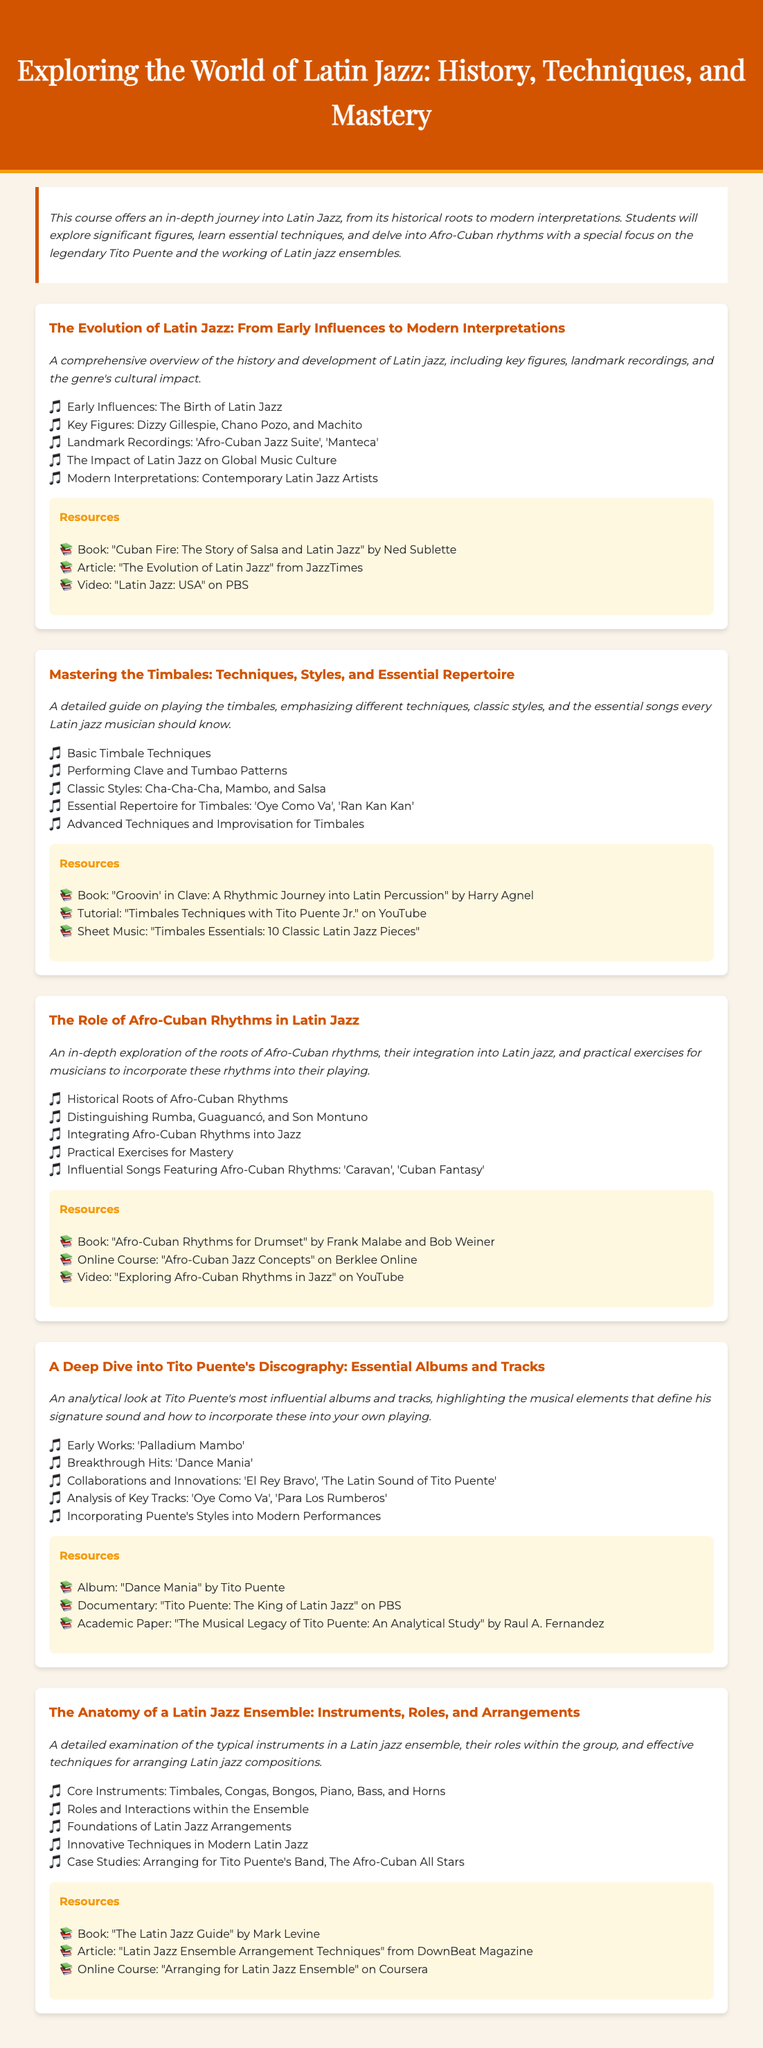What is the title of the course? The title of the course is provided at the top of the document, which highlights the key themes of the syllabus.
Answer: Exploring the World of Latin Jazz: History, Techniques, and Mastery Who is a key figure mentioned in the module about the evolution of Latin jazz? This question looks for specific names listed under the 'Key Figures' bullet point in the first module.
Answer: Dizzy Gillespie What is one essential song every Latin jazz musician should know according to the timbales module? This question focuses on identifying a specific song listed as part of the essential repertoire in the timbales section.
Answer: Oye Como Va How many major modules are included in the syllabus? The number of major modules is stated by counting the distinct sections outlined in the document.
Answer: Five Which book is recommended for learning about Afro-Cuban rhythms? The question looks for a specific title indicated in the resources section of the Afro-Cuban rhythms module.
Answer: Afro-Cuban Rhythms for Drumset What are the core instruments listed in the anatomy of a Latin jazz ensemble module? This question asks for the specific instruments mentioned in the 'Core Instruments' bullet point.
Answer: Timbales, Congas, Bongos, Piano, Bass, and Horns What year is associated with Tito Puente's album 'Dance Mania'? The question seeks to draw from the significant works listed in the Tito Puente discography section, focusing on one of the albums.
Answer: 1958 What technique is emphasized in the timbales module? This question inquires about the main focus presented in the timbales section, looking for a specific aspect of playing.
Answer: Clave and Tumbao Patterns What is one practical exercise mentioned in the Afro-Cuban rhythms module? This question prompts to identify practical exercises outlined in the relevant module and looks for a specific mention.
Answer: Practical Exercises for Mastery 